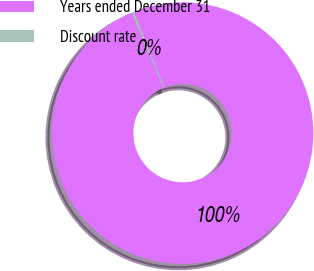Convert chart to OTSL. <chart><loc_0><loc_0><loc_500><loc_500><pie_chart><fcel>Years ended December 31<fcel>Discount rate<nl><fcel>99.71%<fcel>0.29%<nl></chart> 